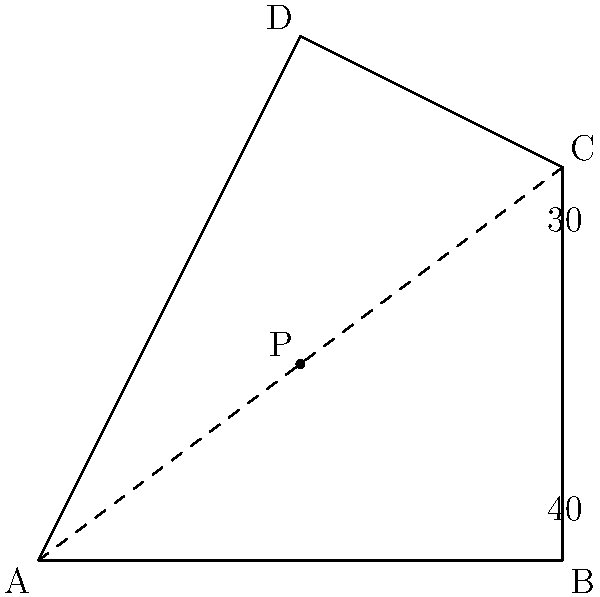In the college quad represented by quadrilateral ABCD, a new path AP is proposed to optimize foot traffic. Given that angle BAC is 40° and angle ACP is 30°, what is the measure of angle PAD? Let's approach this step-by-step:

1) In a quadrilateral, the sum of interior angles is always 360°.

2) We're given two angles in triangle ACP:
   - Angle BAC = 40°
   - Angle ACP = 30°

3) To find angle PAD, we need to find the sum of angles in triangle ACP:
   $$\angle BAC + \angle ACP + \angle PAD = 180°$$ (sum of angles in a triangle)

4) Substituting the known values:
   $$40° + 30° + \angle PAD = 180°$$

5) Simplifying:
   $$70° + \angle PAD = 180°$$

6) Solving for angle PAD:
   $$\angle PAD = 180° - 70° = 110°$$

Therefore, the measure of angle PAD is 110°.
Answer: 110° 